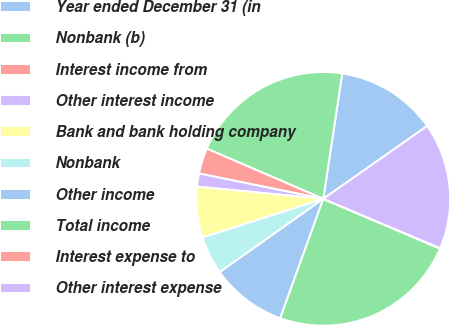Convert chart to OTSL. <chart><loc_0><loc_0><loc_500><loc_500><pie_chart><fcel>Year ended December 31 (in<fcel>Nonbank (b)<fcel>Interest income from<fcel>Other interest income<fcel>Bank and bank holding company<fcel>Nonbank<fcel>Other income<fcel>Total income<fcel>Interest expense to<fcel>Other interest expense<nl><fcel>12.88%<fcel>20.9%<fcel>3.27%<fcel>1.67%<fcel>6.47%<fcel>4.87%<fcel>9.68%<fcel>24.1%<fcel>0.06%<fcel>16.09%<nl></chart> 